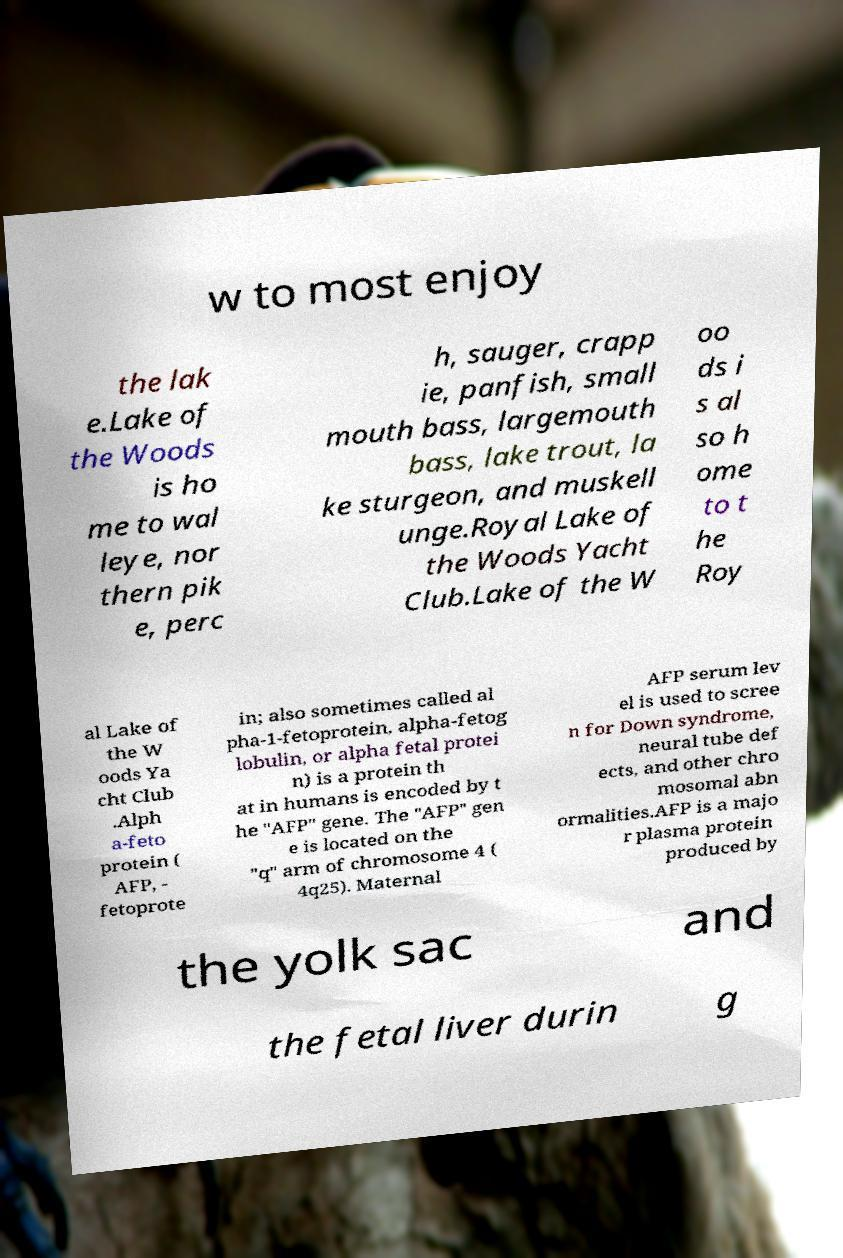Please read and relay the text visible in this image. What does it say? w to most enjoy the lak e.Lake of the Woods is ho me to wal leye, nor thern pik e, perc h, sauger, crapp ie, panfish, small mouth bass, largemouth bass, lake trout, la ke sturgeon, and muskell unge.Royal Lake of the Woods Yacht Club.Lake of the W oo ds i s al so h ome to t he Roy al Lake of the W oods Ya cht Club .Alph a-feto protein ( AFP, - fetoprote in; also sometimes called al pha-1-fetoprotein, alpha-fetog lobulin, or alpha fetal protei n) is a protein th at in humans is encoded by t he "AFP" gene. The "AFP" gen e is located on the "q" arm of chromosome 4 ( 4q25). Maternal AFP serum lev el is used to scree n for Down syndrome, neural tube def ects, and other chro mosomal abn ormalities.AFP is a majo r plasma protein produced by the yolk sac and the fetal liver durin g 